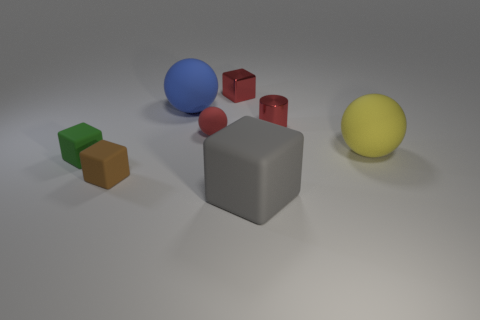Subtract all big blue balls. How many balls are left? 2 Add 1 blue balls. How many objects exist? 9 Subtract 3 cubes. How many cubes are left? 1 Subtract all red balls. How many balls are left? 2 Subtract all spheres. How many objects are left? 5 Subtract all gray cubes. How many red balls are left? 1 Subtract 0 green spheres. How many objects are left? 8 Subtract all green cylinders. Subtract all brown blocks. How many cylinders are left? 1 Subtract all large yellow spheres. Subtract all tiny red objects. How many objects are left? 4 Add 3 large blue spheres. How many large blue spheres are left? 4 